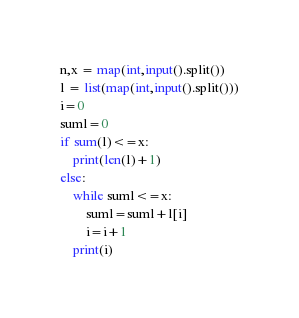Convert code to text. <code><loc_0><loc_0><loc_500><loc_500><_Python_>n,x = map(int,input().split())
l = list(map(int,input().split()))
i=0
suml=0
if sum(l)<=x:
    print(len(l)+1)
else:
    while suml<=x:
        suml=suml+l[i]
        i=i+1
    print(i)
</code> 